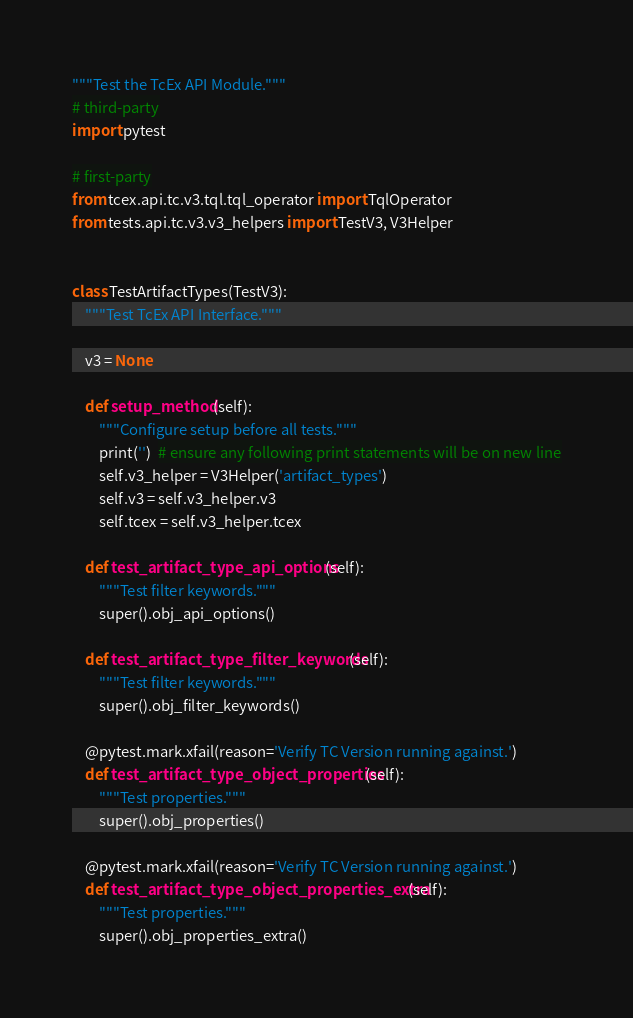<code> <loc_0><loc_0><loc_500><loc_500><_Python_>"""Test the TcEx API Module."""
# third-party
import pytest

# first-party
from tcex.api.tc.v3.tql.tql_operator import TqlOperator
from tests.api.tc.v3.v3_helpers import TestV3, V3Helper


class TestArtifactTypes(TestV3):
    """Test TcEx API Interface."""

    v3 = None

    def setup_method(self):
        """Configure setup before all tests."""
        print('')  # ensure any following print statements will be on new line
        self.v3_helper = V3Helper('artifact_types')
        self.v3 = self.v3_helper.v3
        self.tcex = self.v3_helper.tcex

    def test_artifact_type_api_options(self):
        """Test filter keywords."""
        super().obj_api_options()

    def test_artifact_type_filter_keywords(self):
        """Test filter keywords."""
        super().obj_filter_keywords()

    @pytest.mark.xfail(reason='Verify TC Version running against.')
    def test_artifact_type_object_properties(self):
        """Test properties."""
        super().obj_properties()

    @pytest.mark.xfail(reason='Verify TC Version running against.')
    def test_artifact_type_object_properties_extra(self):
        """Test properties."""
        super().obj_properties_extra()
</code> 